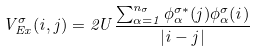<formula> <loc_0><loc_0><loc_500><loc_500>V _ { E x } ^ { \sigma } ( i , j ) = 2 U \frac { \sum _ { \alpha = 1 } ^ { n _ { \sigma } } \phi _ { \alpha } ^ { \sigma * } ( j ) \phi _ { \alpha } ^ { \sigma } ( i ) } { | i - j | }</formula> 